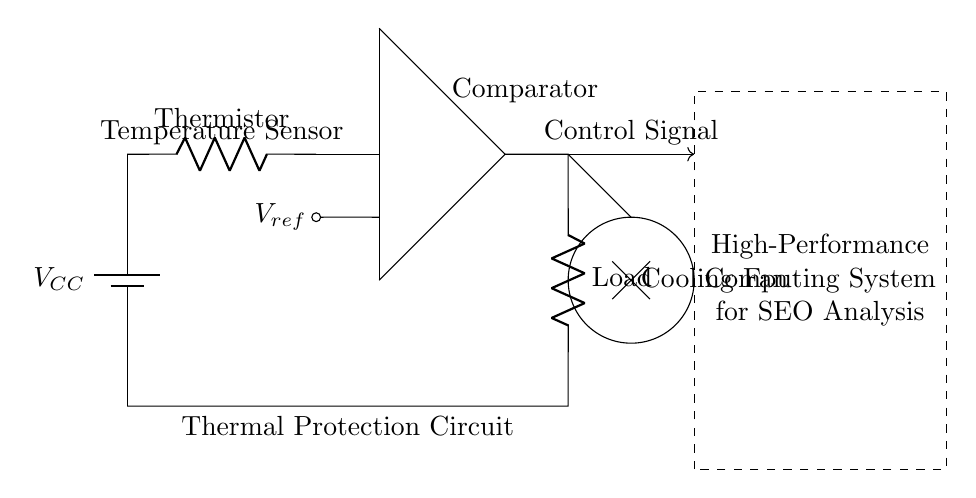What component is used to measure temperature? The thermistor is used to measure temperature; it's clearly labeled in the circuit diagram and positioned at the top as part of the thermal protection mechanism.
Answer: Thermistor What does the comparator do in this circuit? The comparator compares the voltage from the thermistor to a reference voltage, determining whether to activate the cooling fan or not based on temperature levels.
Answer: Activate cooling fan What voltage is labeled as Vref? Vref is indicated as a reference voltage in the circuit, connected to the comparator to set a temperature threshold for triggering the load. The exact value is not given in the diagram but it serves as a comparison point.
Answer: Reference voltage What is the function of the cooling fan? The cooling fan is activated by the output from the comparator to dissipate heat when the temperature exceeds the threshold, ensuring the system remains within operational limits.
Answer: Dissipate heat How many major components are in this thermal protection circuit? There are three major components: the thermistor, the comparator, and the cooling fan, each serving a specific role in the thermal protection mechanism.
Answer: Three components At what location is the Load connected in the circuit? The Load is connected at the output of the comparator; the line extends down connecting back to the power supply, indicating it is part of the thermal management system.
Answer: At the output of the comparator 